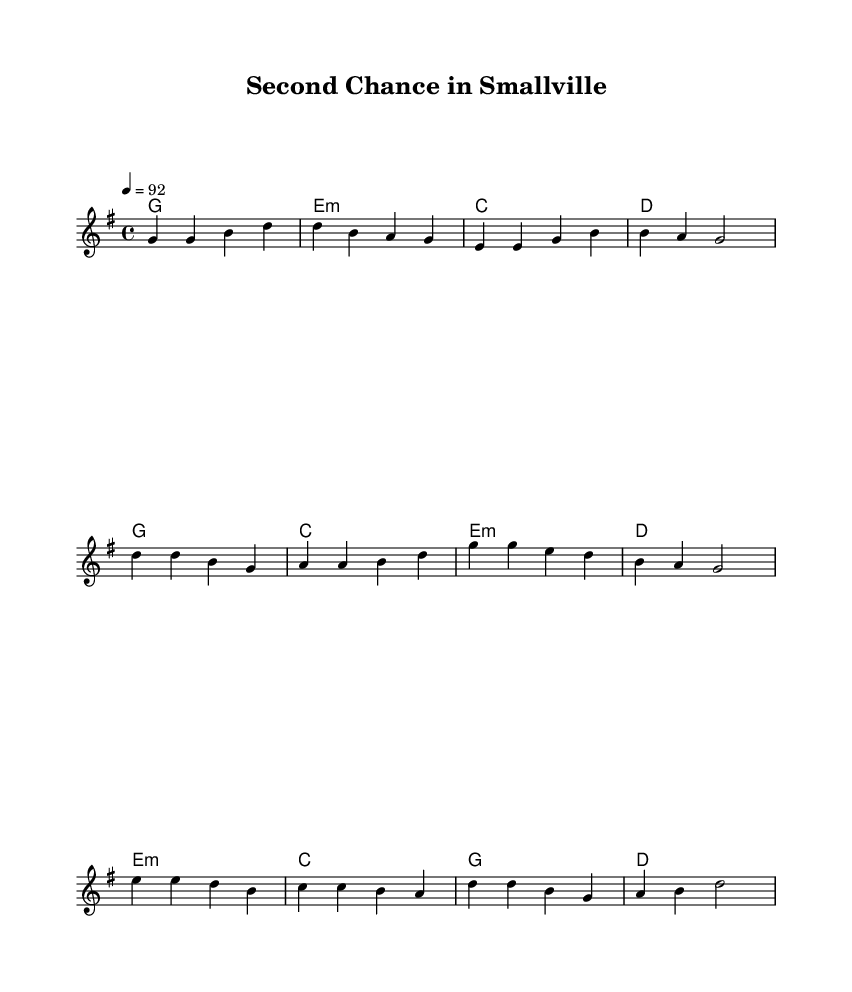What is the key signature of this music? The key signature is G major, which has one sharp (F#). This can be identified in the key signature indication at the beginning of the sheet music.
Answer: G major What is the time signature of this piece? The time signature is 4/4, meaning there are four beats in each measure and the quarter note gets one beat. This is indicated at the beginning of the sheet music.
Answer: 4/4 What is the tempo marking of the song? The tempo marking is 92 beats per minute, indicated as "4 = 92" at the beginning of the score, which suggests the speed at which the piece should be played.
Answer: 92 How many measures are in the verse section? The verse section consists of four measures, as represented visually in the notation. Each group of notes separated by vertical lines represents a measure.
Answer: 4 What is the structure of the song (verse, chorus, bridge)? The structure is verse, chorus, and bridge, as indicated in the layout of the lyrics and their placement throughout the music. This organization is a common structure in country songs, highlighting personal storytelling.
Answer: Verse, Chorus, Bridge What emotion does the song convey based on its title and lyrics? The song conveys hope and resilience, as suggested by the title "Second Chance in Smallville" and the lyrics which express starting over after difficulties. These themes are prevalent in modern country music, focusing on personal struggles and recovery.
Answer: Hope and resilience 